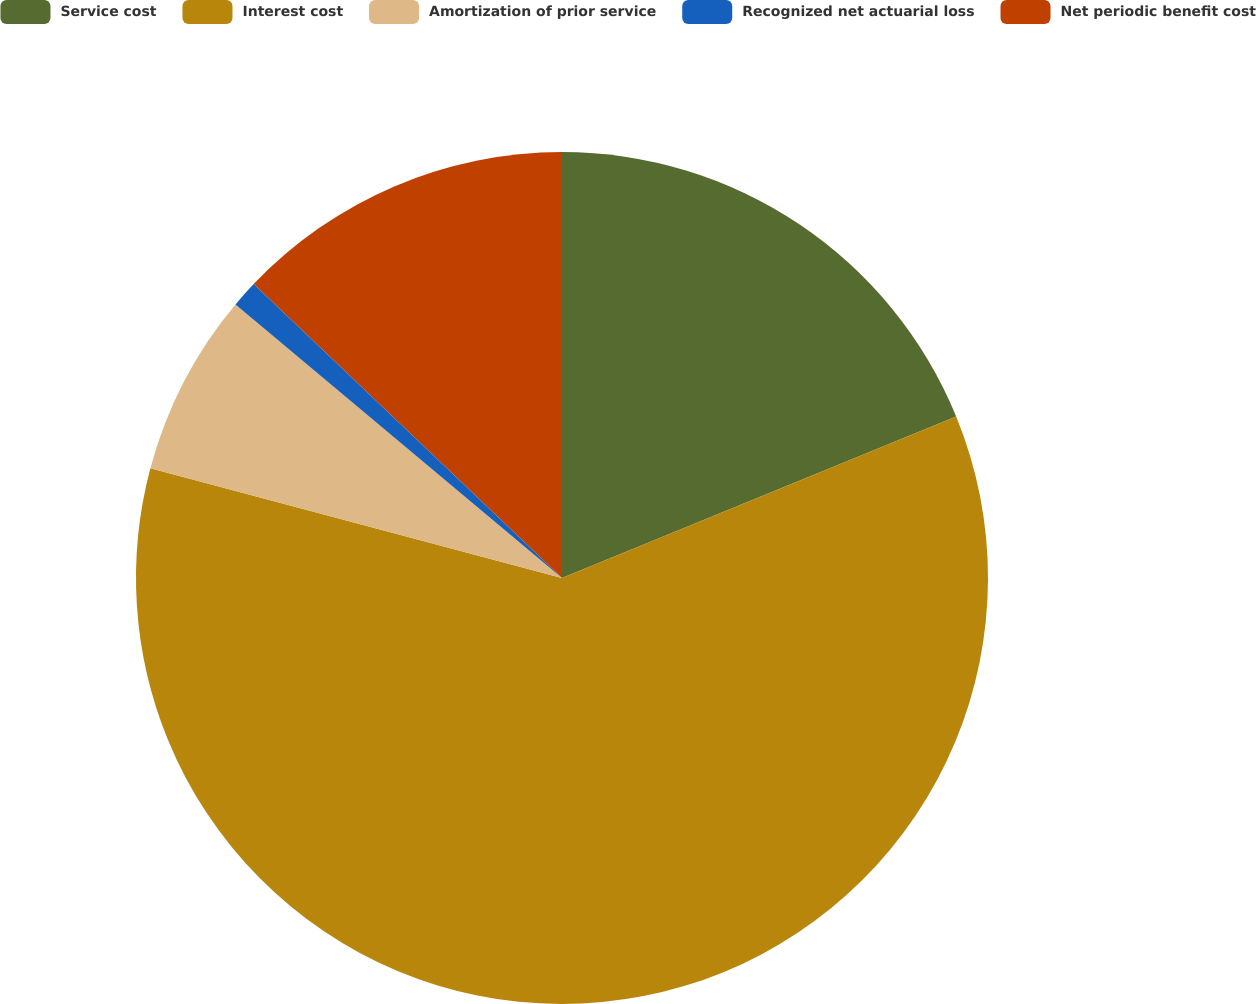<chart> <loc_0><loc_0><loc_500><loc_500><pie_chart><fcel>Service cost<fcel>Interest cost<fcel>Amortization of prior service<fcel>Recognized net actuarial loss<fcel>Net periodic benefit cost<nl><fcel>18.81%<fcel>60.34%<fcel>6.95%<fcel>1.02%<fcel>12.88%<nl></chart> 